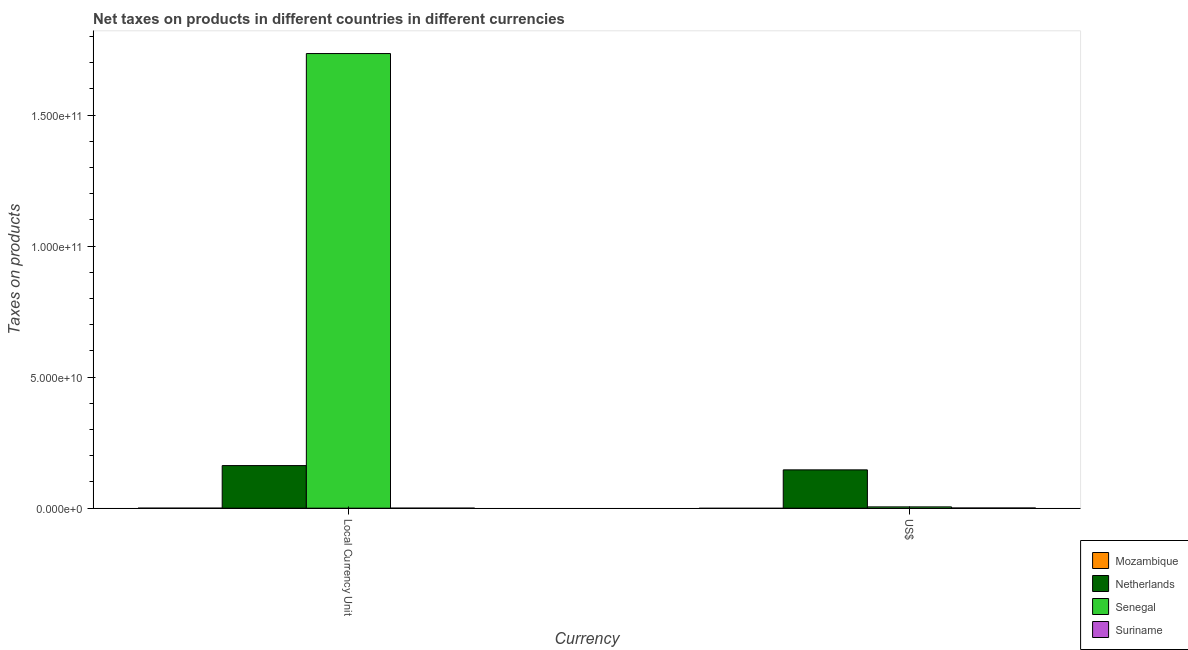How many different coloured bars are there?
Your answer should be very brief. 3. Are the number of bars on each tick of the X-axis equal?
Provide a succinct answer. Yes. How many bars are there on the 2nd tick from the left?
Give a very brief answer. 3. What is the label of the 1st group of bars from the left?
Your answer should be very brief. Local Currency Unit. Across all countries, what is the maximum net taxes in constant 2005 us$?
Keep it short and to the point. 1.73e+11. What is the total net taxes in us$ in the graph?
Offer a terse response. 1.52e+1. What is the difference between the net taxes in us$ in Senegal and that in Suriname?
Provide a succinct answer. 4.28e+08. What is the difference between the net taxes in constant 2005 us$ in Netherlands and the net taxes in us$ in Senegal?
Ensure brevity in your answer.  1.58e+1. What is the average net taxes in constant 2005 us$ per country?
Your answer should be very brief. 4.74e+1. What is the difference between the net taxes in constant 2005 us$ and net taxes in us$ in Suriname?
Give a very brief answer. -7.31e+07. In how many countries, is the net taxes in us$ greater than 100000000000 units?
Make the answer very short. 0. What is the ratio of the net taxes in us$ in Netherlands to that in Suriname?
Make the answer very short. 199.73. Is the net taxes in constant 2005 us$ in Suriname less than that in Netherlands?
Ensure brevity in your answer.  Yes. Are all the bars in the graph horizontal?
Your answer should be compact. No. Does the graph contain any zero values?
Offer a very short reply. Yes. Does the graph contain grids?
Keep it short and to the point. No. Where does the legend appear in the graph?
Provide a succinct answer. Bottom right. How are the legend labels stacked?
Offer a terse response. Vertical. What is the title of the graph?
Offer a terse response. Net taxes on products in different countries in different currencies. Does "Euro area" appear as one of the legend labels in the graph?
Offer a very short reply. No. What is the label or title of the X-axis?
Ensure brevity in your answer.  Currency. What is the label or title of the Y-axis?
Make the answer very short. Taxes on products. What is the Taxes on products in Mozambique in Local Currency Unit?
Provide a succinct answer. 0. What is the Taxes on products of Netherlands in Local Currency Unit?
Give a very brief answer. 1.63e+1. What is the Taxes on products of Senegal in Local Currency Unit?
Offer a terse response. 1.73e+11. What is the Taxes on products of Suriname in Local Currency Unit?
Your response must be concise. 1.46e+05. What is the Taxes on products in Mozambique in US$?
Provide a short and direct response. 0. What is the Taxes on products in Netherlands in US$?
Your response must be concise. 1.46e+1. What is the Taxes on products in Senegal in US$?
Make the answer very short. 5.01e+08. What is the Taxes on products of Suriname in US$?
Provide a short and direct response. 7.32e+07. Across all Currency, what is the maximum Taxes on products in Netherlands?
Your response must be concise. 1.63e+1. Across all Currency, what is the maximum Taxes on products in Senegal?
Your answer should be compact. 1.73e+11. Across all Currency, what is the maximum Taxes on products in Suriname?
Ensure brevity in your answer.  7.32e+07. Across all Currency, what is the minimum Taxes on products in Netherlands?
Your answer should be very brief. 1.46e+1. Across all Currency, what is the minimum Taxes on products in Senegal?
Provide a short and direct response. 5.01e+08. Across all Currency, what is the minimum Taxes on products of Suriname?
Give a very brief answer. 1.46e+05. What is the total Taxes on products of Netherlands in the graph?
Ensure brevity in your answer.  3.09e+1. What is the total Taxes on products in Senegal in the graph?
Provide a short and direct response. 1.74e+11. What is the total Taxes on products of Suriname in the graph?
Keep it short and to the point. 7.33e+07. What is the difference between the Taxes on products of Netherlands in Local Currency Unit and that in US$?
Your answer should be very brief. 1.63e+09. What is the difference between the Taxes on products in Senegal in Local Currency Unit and that in US$?
Make the answer very short. 1.73e+11. What is the difference between the Taxes on products in Suriname in Local Currency Unit and that in US$?
Make the answer very short. -7.31e+07. What is the difference between the Taxes on products of Netherlands in Local Currency Unit and the Taxes on products of Senegal in US$?
Give a very brief answer. 1.58e+1. What is the difference between the Taxes on products of Netherlands in Local Currency Unit and the Taxes on products of Suriname in US$?
Your answer should be compact. 1.62e+1. What is the difference between the Taxes on products in Senegal in Local Currency Unit and the Taxes on products in Suriname in US$?
Give a very brief answer. 1.73e+11. What is the average Taxes on products in Netherlands per Currency?
Provide a short and direct response. 1.54e+1. What is the average Taxes on products of Senegal per Currency?
Keep it short and to the point. 8.70e+1. What is the average Taxes on products in Suriname per Currency?
Make the answer very short. 3.67e+07. What is the difference between the Taxes on products of Netherlands and Taxes on products of Senegal in Local Currency Unit?
Give a very brief answer. -1.57e+11. What is the difference between the Taxes on products of Netherlands and Taxes on products of Suriname in Local Currency Unit?
Offer a very short reply. 1.63e+1. What is the difference between the Taxes on products in Senegal and Taxes on products in Suriname in Local Currency Unit?
Keep it short and to the point. 1.73e+11. What is the difference between the Taxes on products of Netherlands and Taxes on products of Senegal in US$?
Offer a very short reply. 1.41e+1. What is the difference between the Taxes on products of Netherlands and Taxes on products of Suriname in US$?
Your response must be concise. 1.45e+1. What is the difference between the Taxes on products of Senegal and Taxes on products of Suriname in US$?
Offer a terse response. 4.28e+08. What is the ratio of the Taxes on products in Netherlands in Local Currency Unit to that in US$?
Provide a short and direct response. 1.11. What is the ratio of the Taxes on products of Senegal in Local Currency Unit to that in US$?
Your response must be concise. 346.31. What is the ratio of the Taxes on products of Suriname in Local Currency Unit to that in US$?
Offer a terse response. 0. What is the difference between the highest and the second highest Taxes on products of Netherlands?
Give a very brief answer. 1.63e+09. What is the difference between the highest and the second highest Taxes on products in Senegal?
Ensure brevity in your answer.  1.73e+11. What is the difference between the highest and the second highest Taxes on products of Suriname?
Give a very brief answer. 7.31e+07. What is the difference between the highest and the lowest Taxes on products in Netherlands?
Offer a very short reply. 1.63e+09. What is the difference between the highest and the lowest Taxes on products in Senegal?
Offer a very short reply. 1.73e+11. What is the difference between the highest and the lowest Taxes on products of Suriname?
Ensure brevity in your answer.  7.31e+07. 